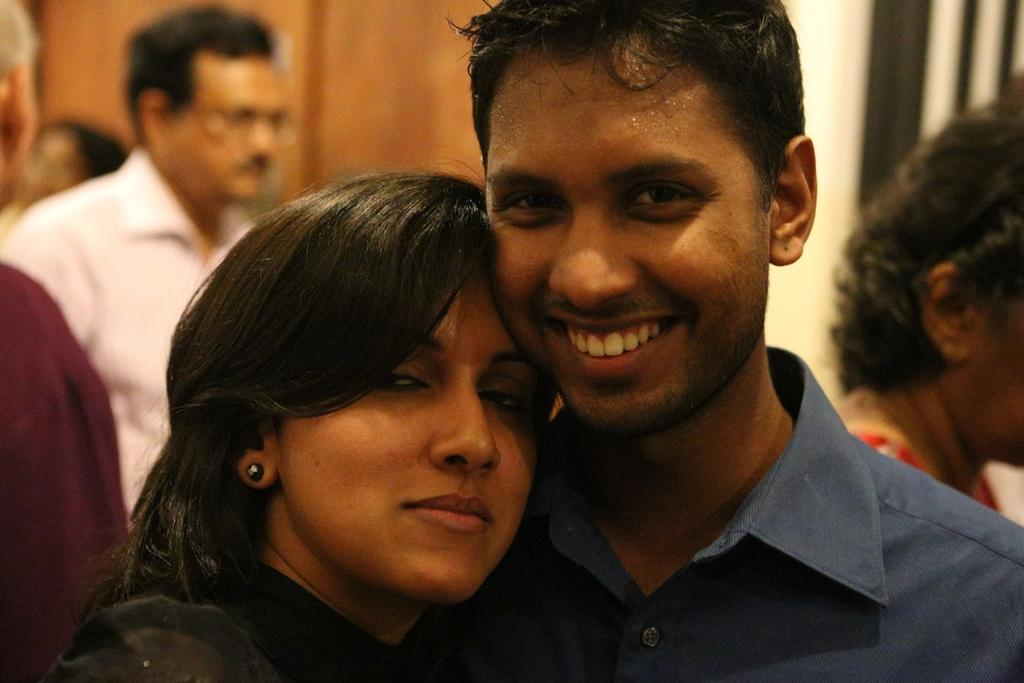How many people are in the foreground of the image? There are two people in the foreground of the image. What are the two people in the foreground doing? The two people are posing for a photo. Can you describe the background of the image? There are other people visible in the background of the image. What type of floor can be seen in the image? There is no information about the floor in the image, as the focus is on the people posing for a photo. 